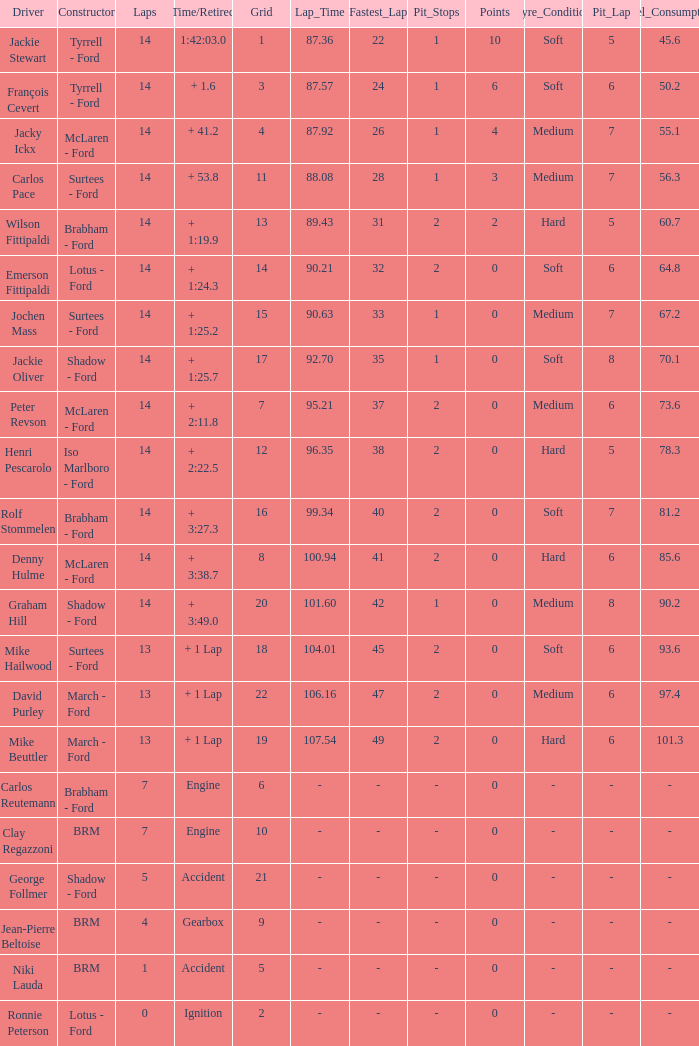What is the low lap total for henri pescarolo with a grad larger than 6? 14.0. 